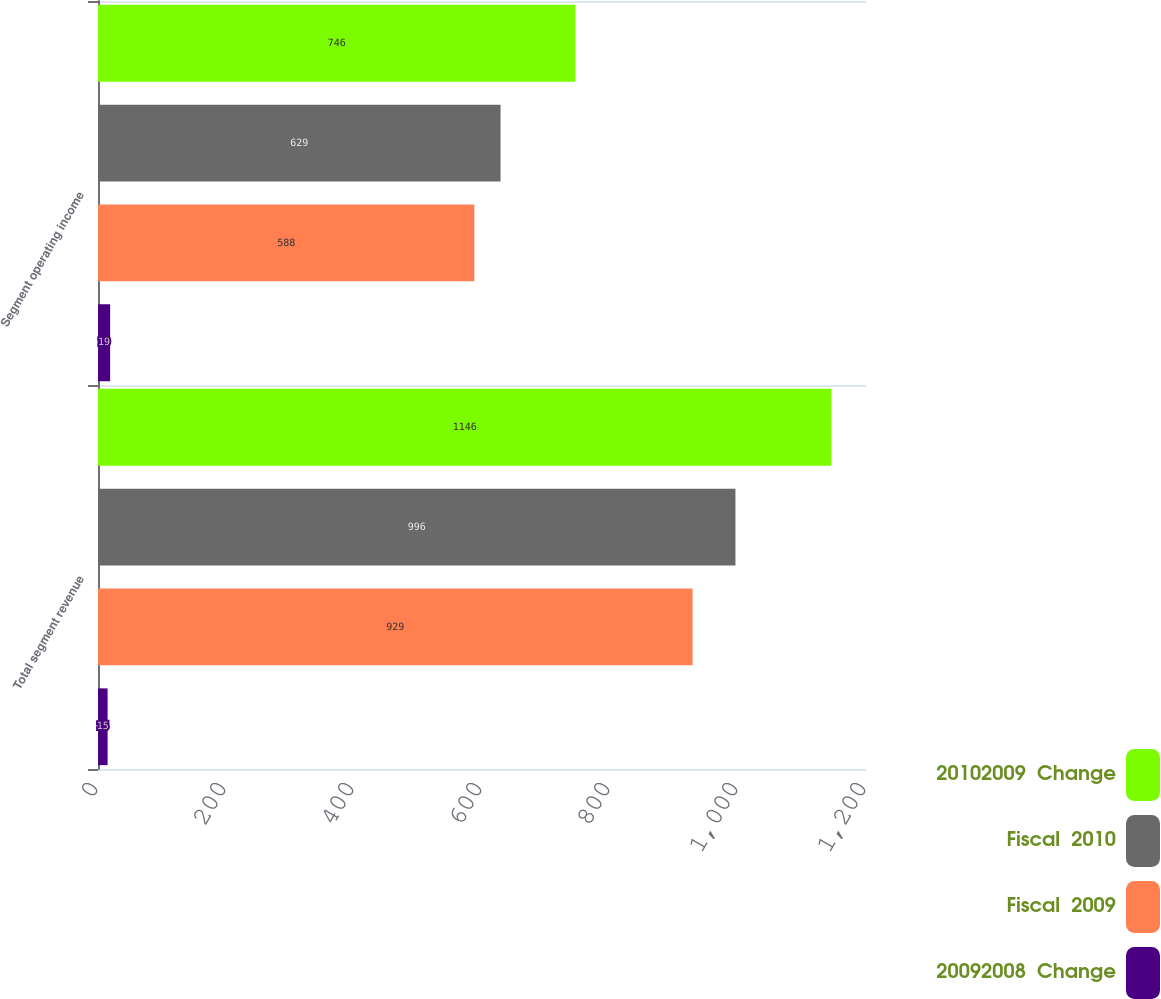<chart> <loc_0><loc_0><loc_500><loc_500><stacked_bar_chart><ecel><fcel>Total segment revenue<fcel>Segment operating income<nl><fcel>20102009  Change<fcel>1146<fcel>746<nl><fcel>Fiscal  2010<fcel>996<fcel>629<nl><fcel>Fiscal  2009<fcel>929<fcel>588<nl><fcel>20092008  Change<fcel>15<fcel>19<nl></chart> 